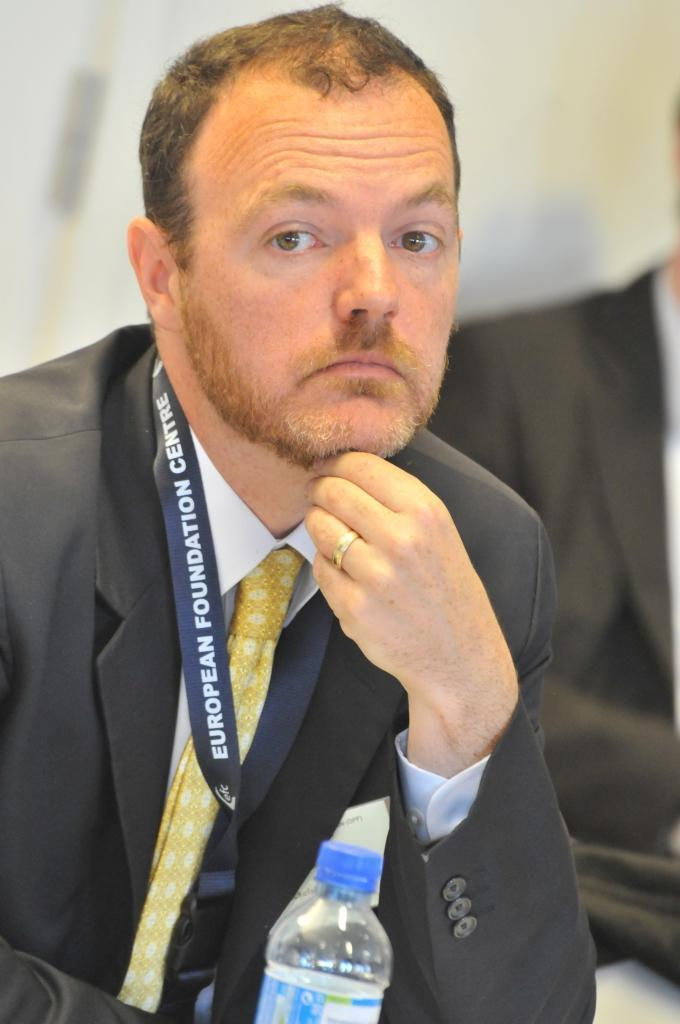How many people are in the image? There are two persons in the image. What is the person on the left wearing? The person on the left is wearing a black suit. What is the person in the black suit doing with their hand? The person in the black suit has their hand under their chin. What object can be seen in the image besides the two persons? There is a bottle visible in the image. What type of food is the person in the black suit eating in the image? There is no food present in the image, and the person in the black suit is not eating. 